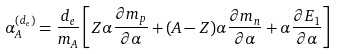<formula> <loc_0><loc_0><loc_500><loc_500>\alpha _ { A } ^ { ( d _ { e } ) } = \frac { d _ { e } } { m _ { A } } \left [ Z \alpha \frac { \partial m _ { p } } { \partial \alpha } + ( A - Z ) \alpha \frac { \partial m _ { n } } { \partial \alpha } + \alpha \frac { \partial E _ { 1 } } { \partial \alpha } \right ]</formula> 